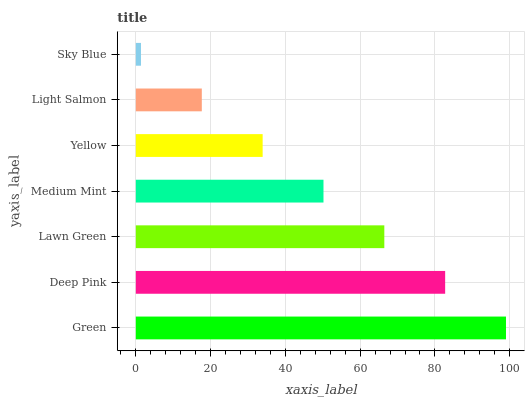Is Sky Blue the minimum?
Answer yes or no. Yes. Is Green the maximum?
Answer yes or no. Yes. Is Deep Pink the minimum?
Answer yes or no. No. Is Deep Pink the maximum?
Answer yes or no. No. Is Green greater than Deep Pink?
Answer yes or no. Yes. Is Deep Pink less than Green?
Answer yes or no. Yes. Is Deep Pink greater than Green?
Answer yes or no. No. Is Green less than Deep Pink?
Answer yes or no. No. Is Medium Mint the high median?
Answer yes or no. Yes. Is Medium Mint the low median?
Answer yes or no. Yes. Is Lawn Green the high median?
Answer yes or no. No. Is Light Salmon the low median?
Answer yes or no. No. 